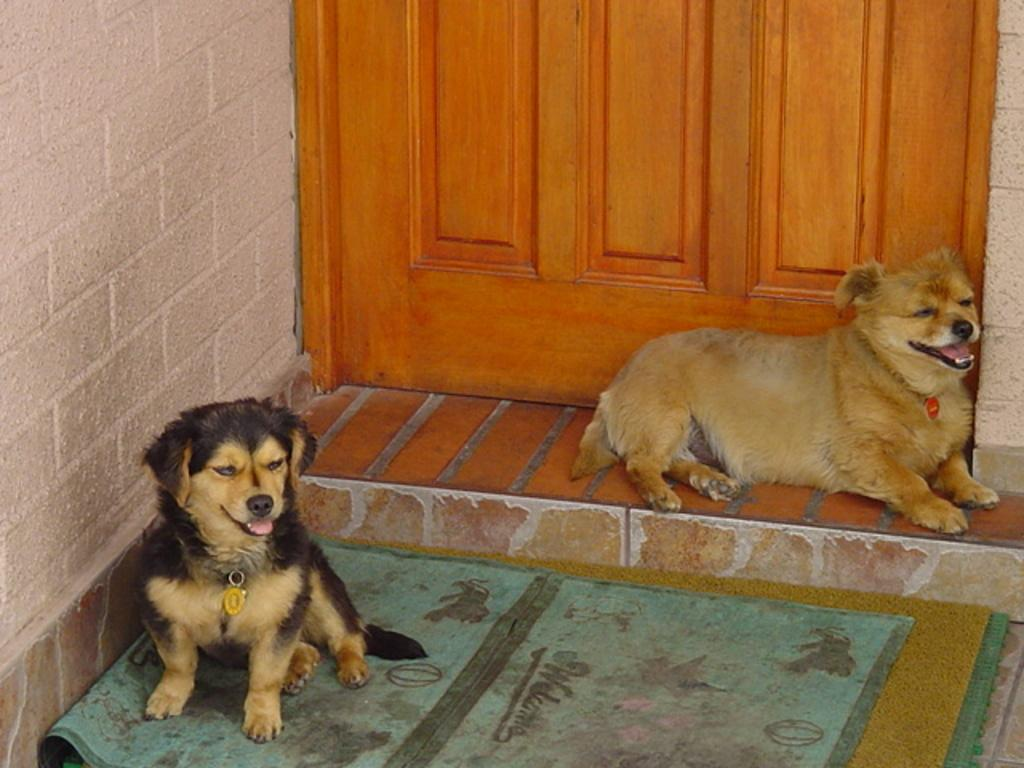What type of animal is on the right side of the image? There is a dog on the right side of the image. Where is the dog located in the image? The dog is on the floor on the right side of the image. What is near the dog on the right side? There is a door near the dog on the right side. What can be seen on the left side of the image? There is a brick wall on the left side of the image. What is the dog doing on the left side of the image? There is another dog sitting on the carpets near the wall on the left side. How does the dog on the right side of the image act in a play? The image does not depict the dog acting in a play; it is simply a dog sitting on the floor. What star is visible in the image? There are no stars visible in the image, as it is a photograph taken indoors. 